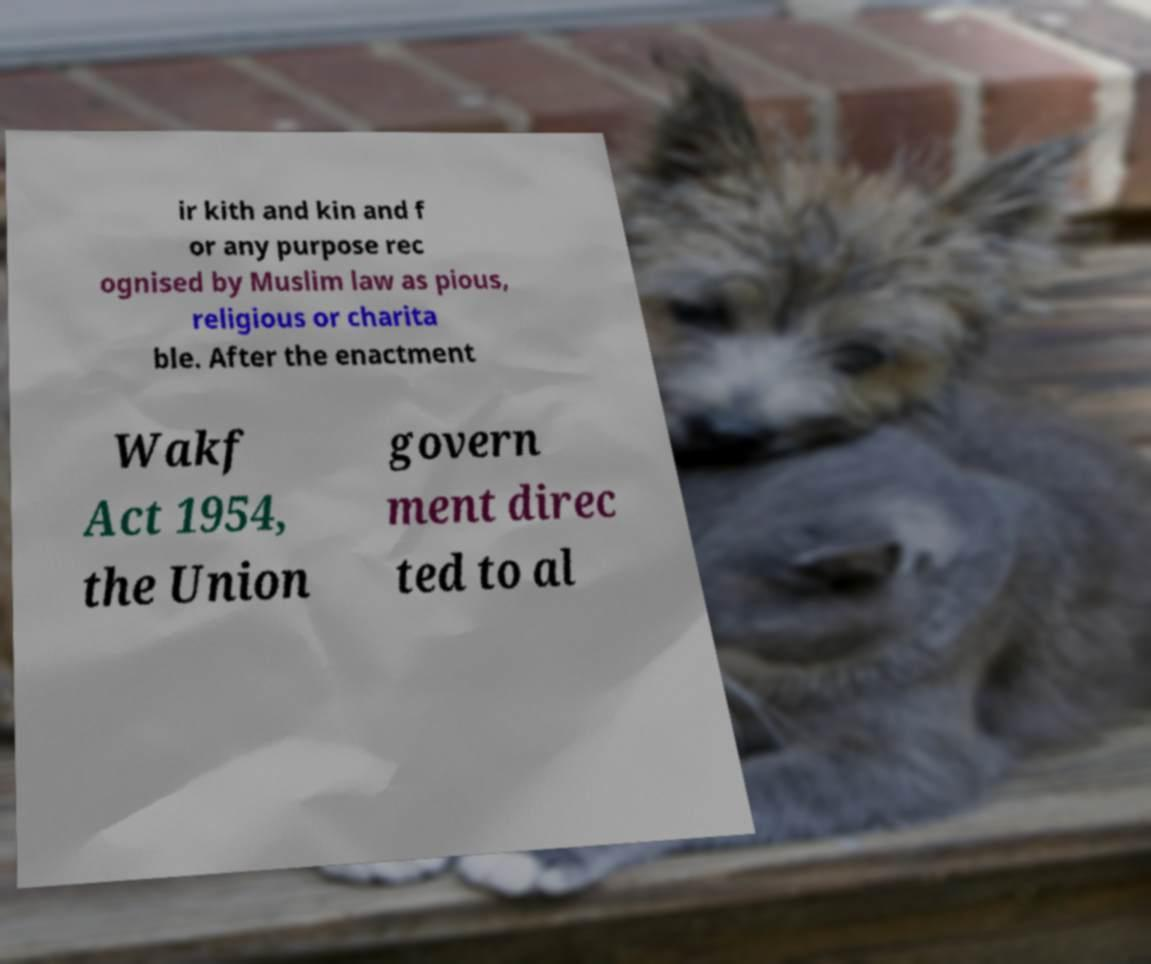There's text embedded in this image that I need extracted. Can you transcribe it verbatim? ir kith and kin and f or any purpose rec ognised by Muslim law as pious, religious or charita ble. After the enactment Wakf Act 1954, the Union govern ment direc ted to al 